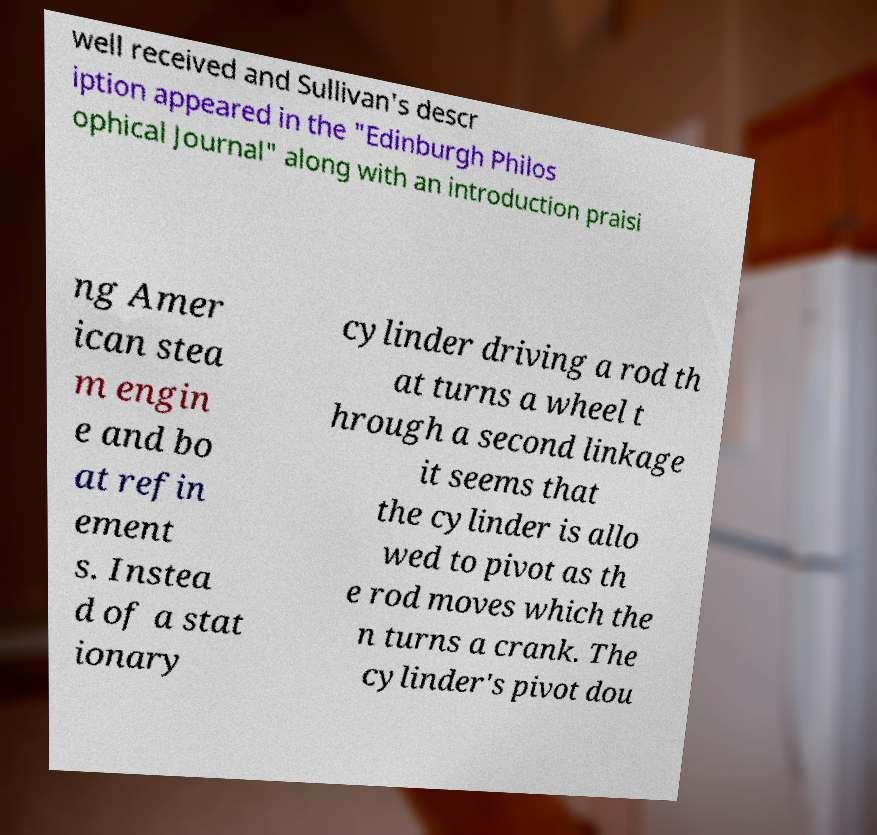Please identify and transcribe the text found in this image. well received and Sullivan's descr iption appeared in the "Edinburgh Philos ophical Journal" along with an introduction praisi ng Amer ican stea m engin e and bo at refin ement s. Instea d of a stat ionary cylinder driving a rod th at turns a wheel t hrough a second linkage it seems that the cylinder is allo wed to pivot as th e rod moves which the n turns a crank. The cylinder's pivot dou 